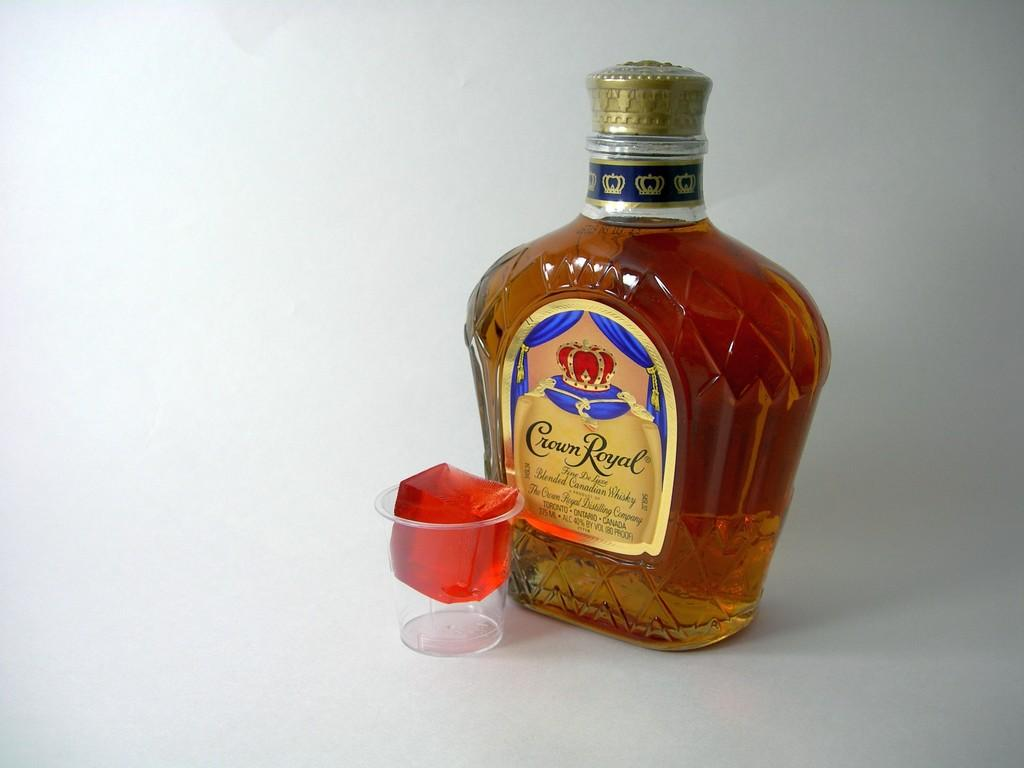<image>
Relay a brief, clear account of the picture shown. A bottle of Crown Royal is next to a jello shot. 